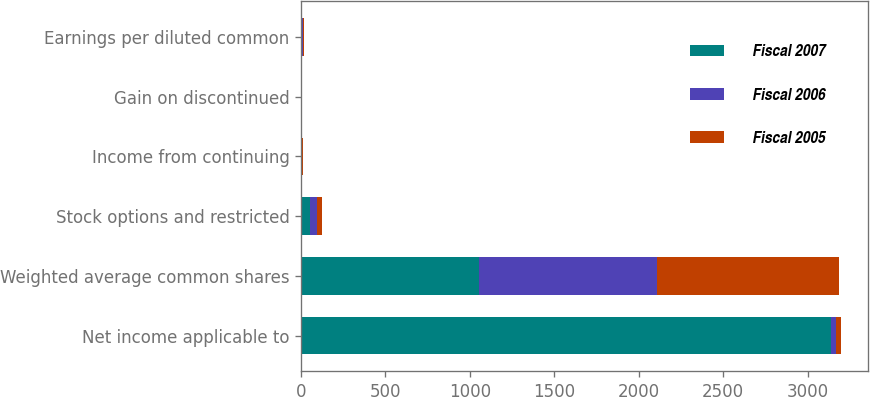<chart> <loc_0><loc_0><loc_500><loc_500><stacked_bar_chart><ecel><fcel>Net income applicable to<fcel>Weighted average common shares<fcel>Stock options and restricted<fcel>Income from continuing<fcel>Gain on discontinued<fcel>Earnings per diluted common<nl><fcel>Fiscal 2007<fcel>3141<fcel>1054<fcel>52<fcel>2.37<fcel>0.61<fcel>2.98<nl><fcel>Fiscal 2006<fcel>30<fcel>1055<fcel>45<fcel>5.99<fcel>1.08<fcel>7.07<nl><fcel>Fiscal 2005<fcel>30<fcel>1080<fcel>30<fcel>4.19<fcel>0.33<fcel>4.57<nl></chart> 